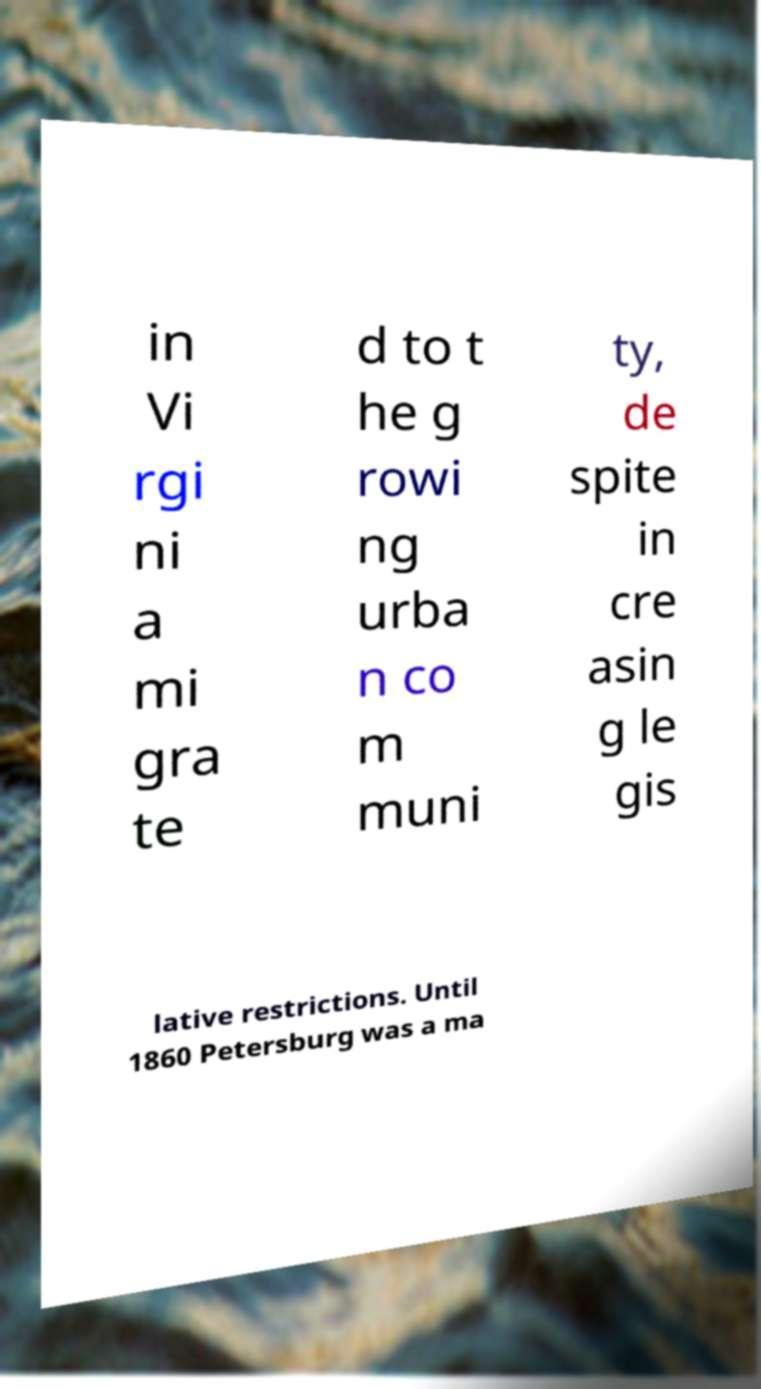I need the written content from this picture converted into text. Can you do that? in Vi rgi ni a mi gra te d to t he g rowi ng urba n co m muni ty, de spite in cre asin g le gis lative restrictions. Until 1860 Petersburg was a ma 